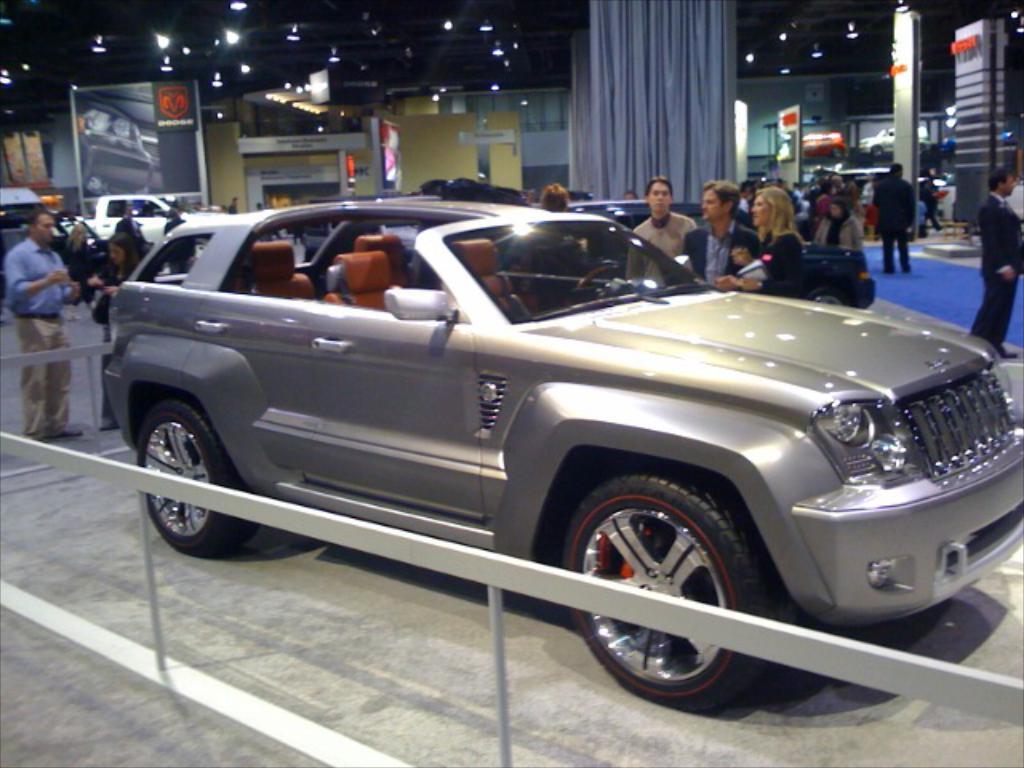Please provide a concise description of this image. In this picture we can see cars and a group of people standing on a platform and in the background we can see banners, lights, curtains. 